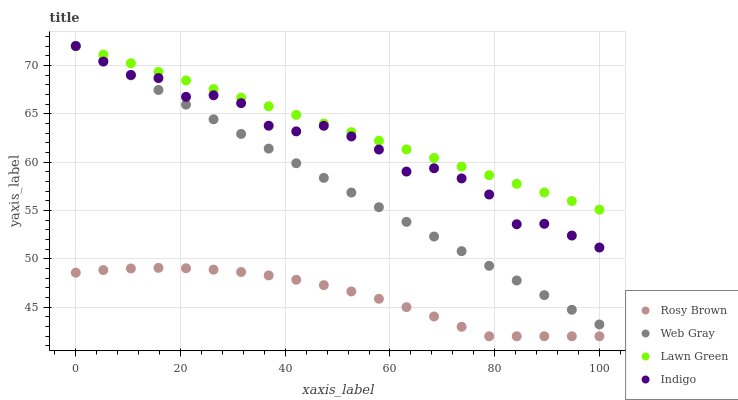Does Rosy Brown have the minimum area under the curve?
Answer yes or no. Yes. Does Lawn Green have the maximum area under the curve?
Answer yes or no. Yes. Does Web Gray have the minimum area under the curve?
Answer yes or no. No. Does Web Gray have the maximum area under the curve?
Answer yes or no. No. Is Lawn Green the smoothest?
Answer yes or no. Yes. Is Indigo the roughest?
Answer yes or no. Yes. Is Rosy Brown the smoothest?
Answer yes or no. No. Is Rosy Brown the roughest?
Answer yes or no. No. Does Rosy Brown have the lowest value?
Answer yes or no. Yes. Does Web Gray have the lowest value?
Answer yes or no. No. Does Indigo have the highest value?
Answer yes or no. Yes. Does Rosy Brown have the highest value?
Answer yes or no. No. Is Rosy Brown less than Lawn Green?
Answer yes or no. Yes. Is Lawn Green greater than Rosy Brown?
Answer yes or no. Yes. Does Web Gray intersect Indigo?
Answer yes or no. Yes. Is Web Gray less than Indigo?
Answer yes or no. No. Is Web Gray greater than Indigo?
Answer yes or no. No. Does Rosy Brown intersect Lawn Green?
Answer yes or no. No. 